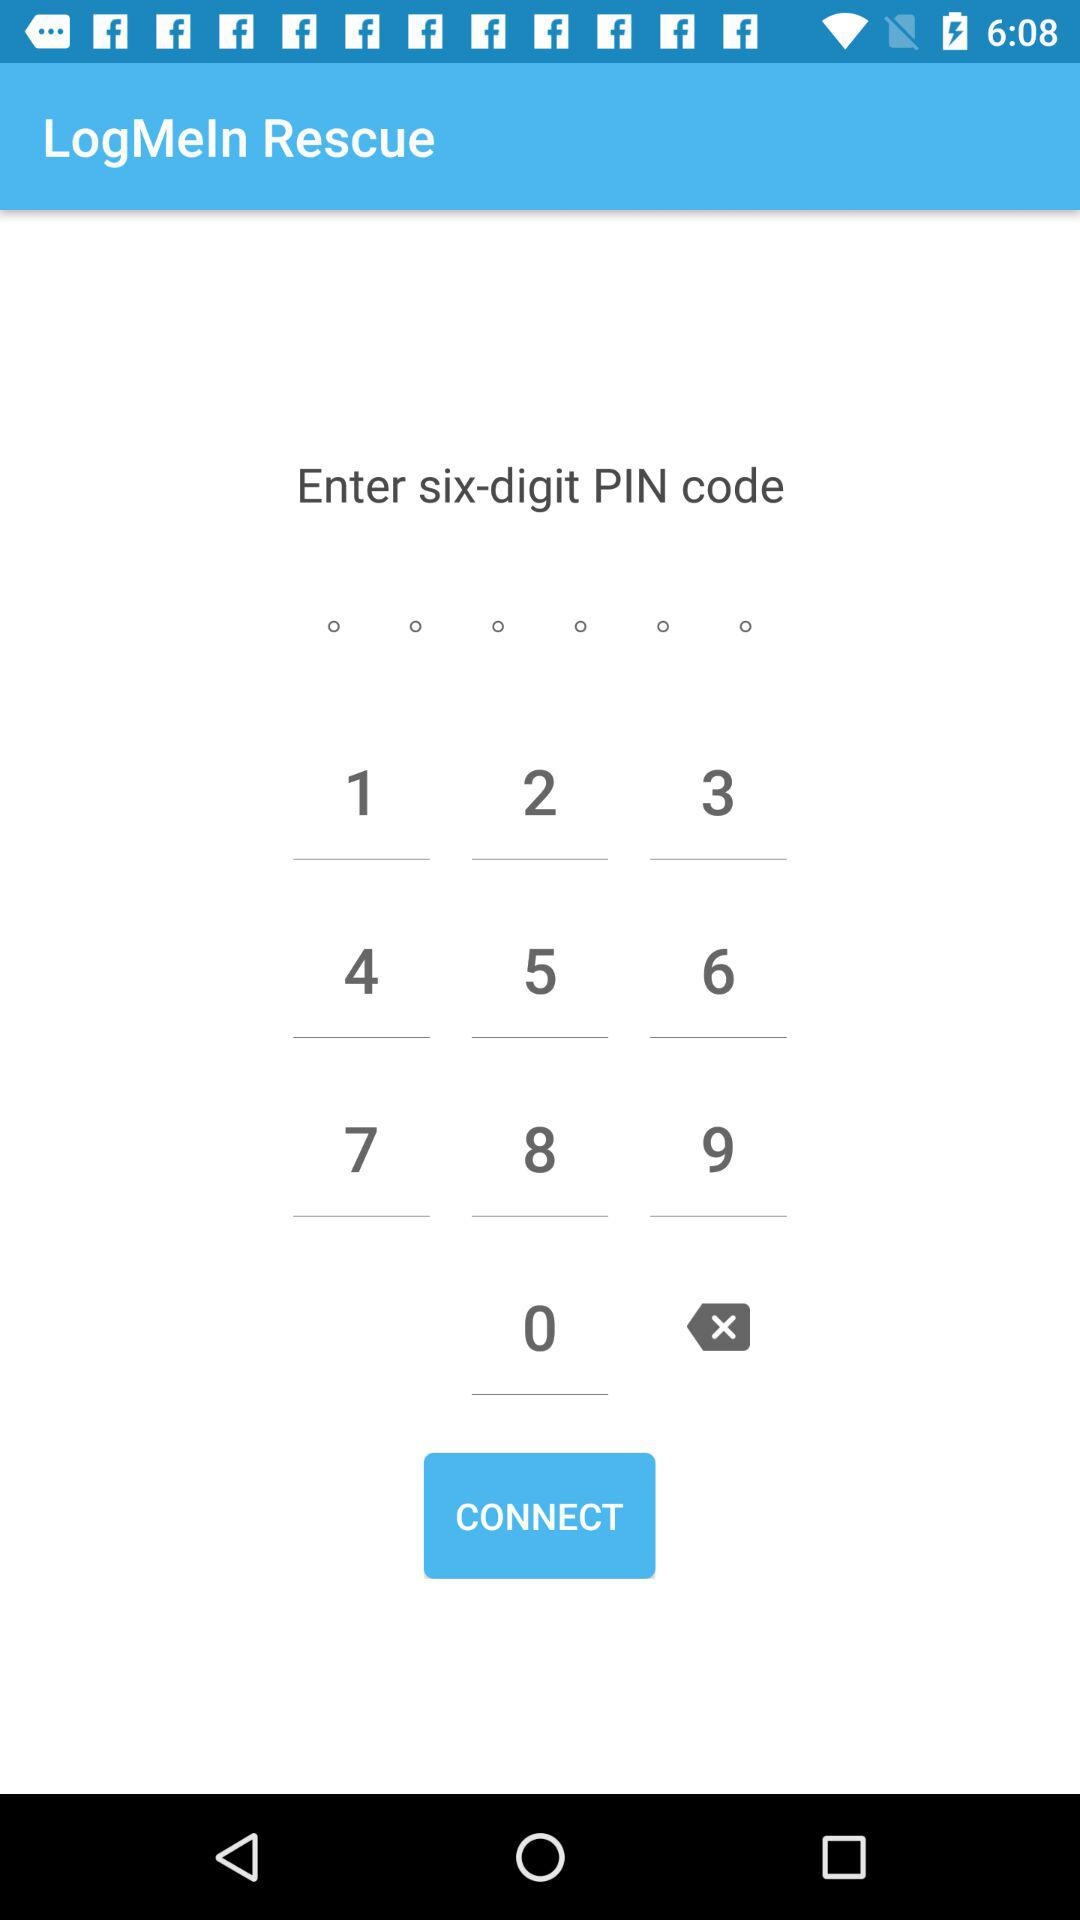What is the app name? The app name is "LogMeIn Rescue". 